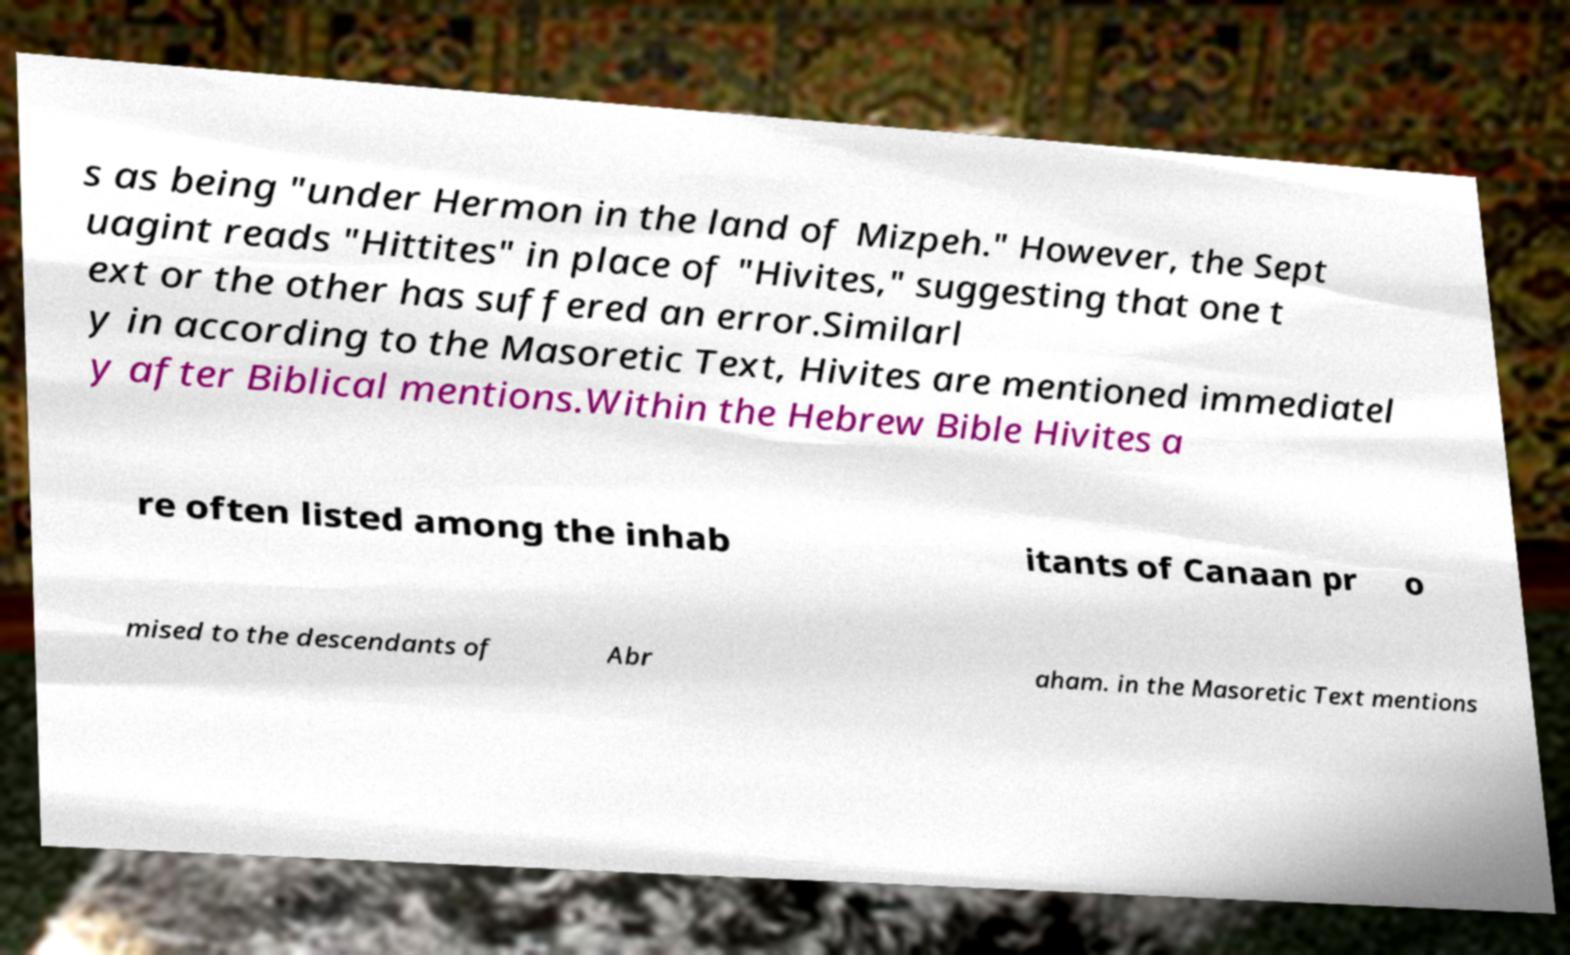What messages or text are displayed in this image? I need them in a readable, typed format. s as being "under Hermon in the land of Mizpeh." However, the Sept uagint reads "Hittites" in place of "Hivites," suggesting that one t ext or the other has suffered an error.Similarl y in according to the Masoretic Text, Hivites are mentioned immediatel y after Biblical mentions.Within the Hebrew Bible Hivites a re often listed among the inhab itants of Canaan pr o mised to the descendants of Abr aham. in the Masoretic Text mentions 